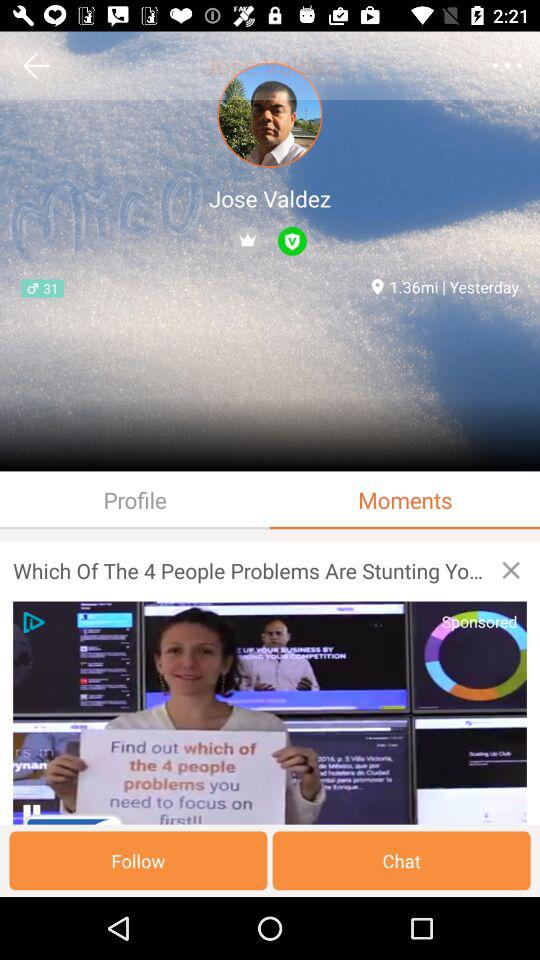How many followers does Jose Valdez have?
Answer the question using a single word or phrase. 31 